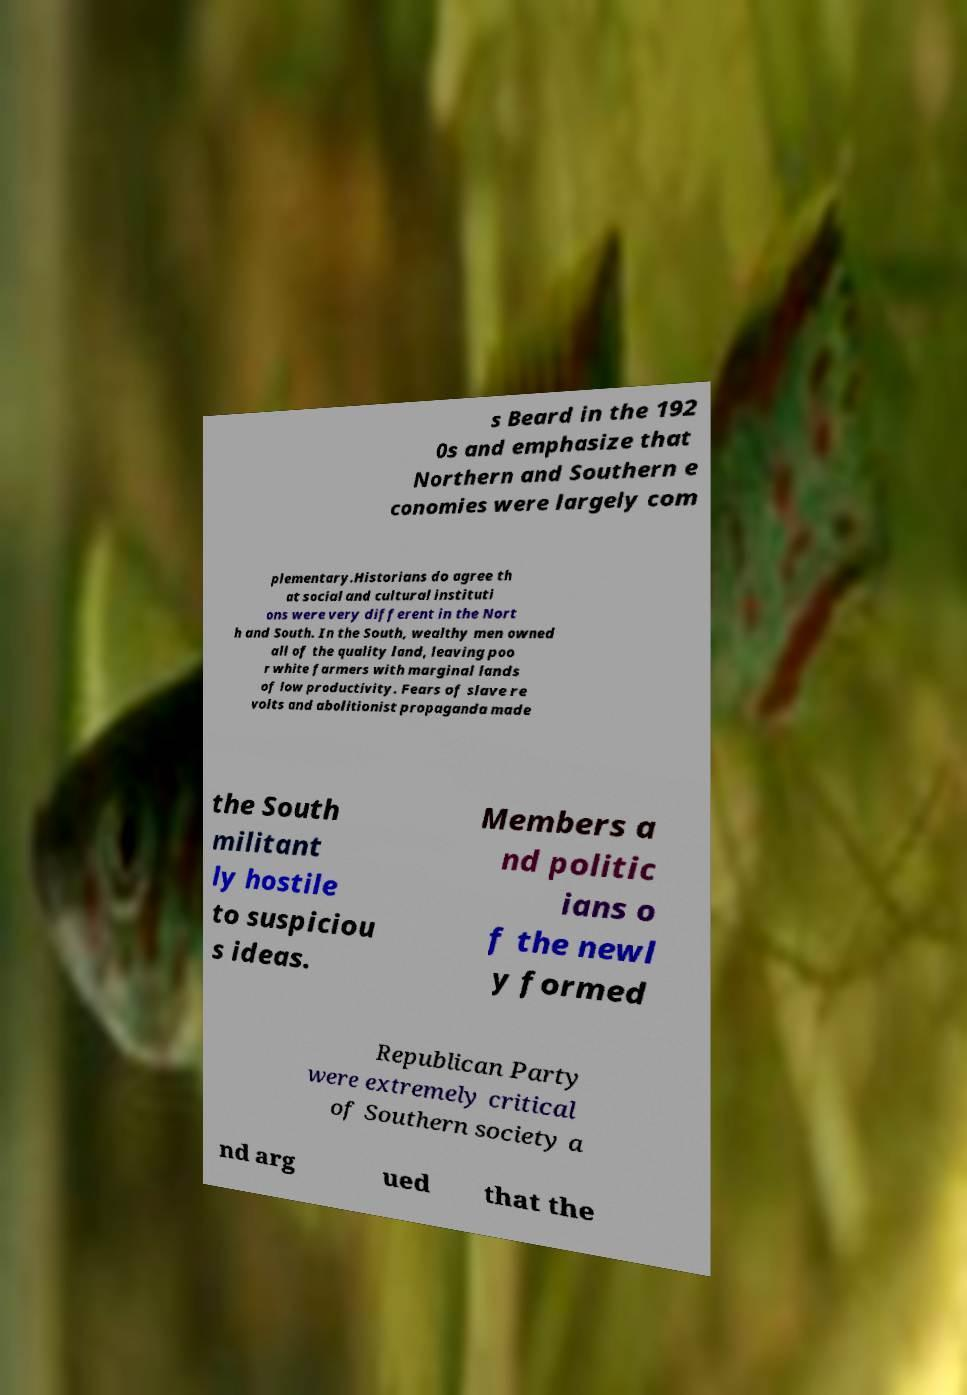Could you extract and type out the text from this image? s Beard in the 192 0s and emphasize that Northern and Southern e conomies were largely com plementary.Historians do agree th at social and cultural instituti ons were very different in the Nort h and South. In the South, wealthy men owned all of the quality land, leaving poo r white farmers with marginal lands of low productivity. Fears of slave re volts and abolitionist propaganda made the South militant ly hostile to suspiciou s ideas. Members a nd politic ians o f the newl y formed Republican Party were extremely critical of Southern society a nd arg ued that the 